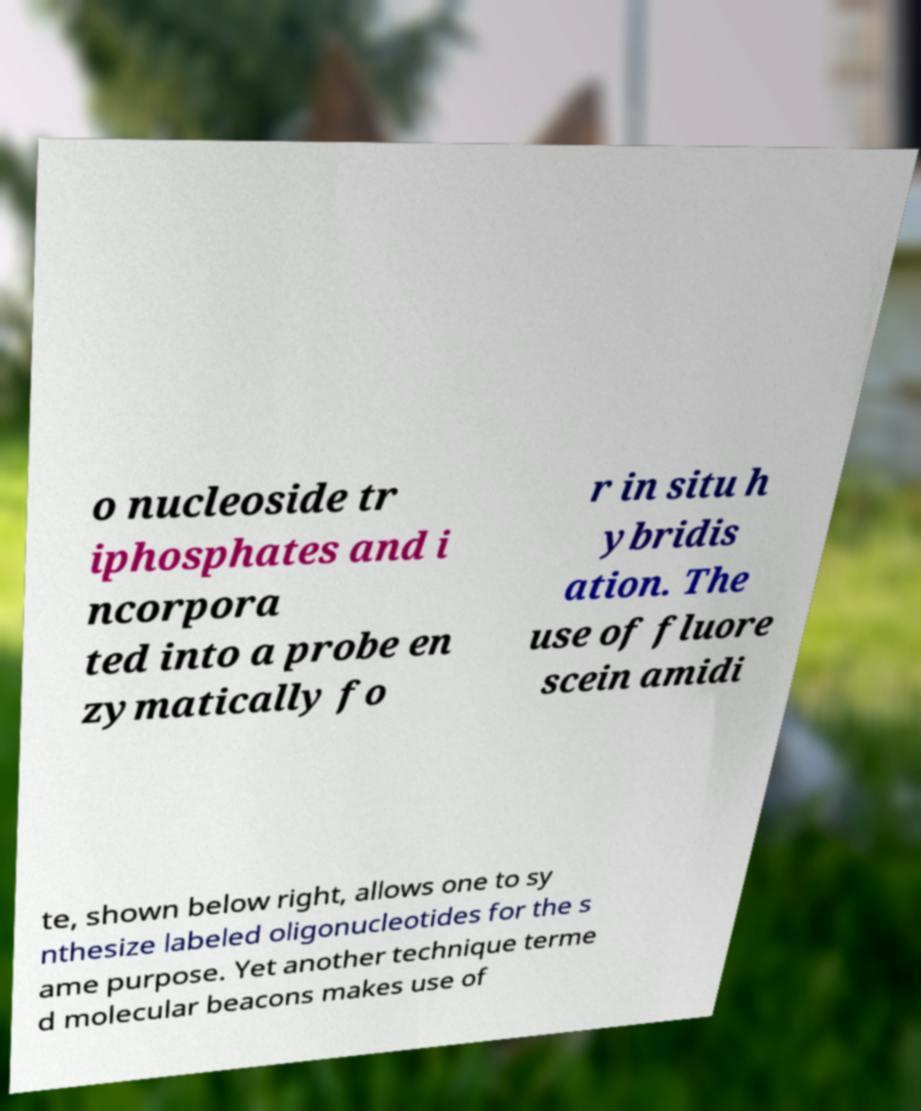Could you assist in decoding the text presented in this image and type it out clearly? o nucleoside tr iphosphates and i ncorpora ted into a probe en zymatically fo r in situ h ybridis ation. The use of fluore scein amidi te, shown below right, allows one to sy nthesize labeled oligonucleotides for the s ame purpose. Yet another technique terme d molecular beacons makes use of 